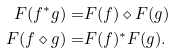Convert formula to latex. <formula><loc_0><loc_0><loc_500><loc_500>F ( f ^ { * } g ) = & F ( f ) \diamond F ( g ) \\ F ( f \diamond g ) = & F ( f ) ^ { * } F ( g ) .</formula> 